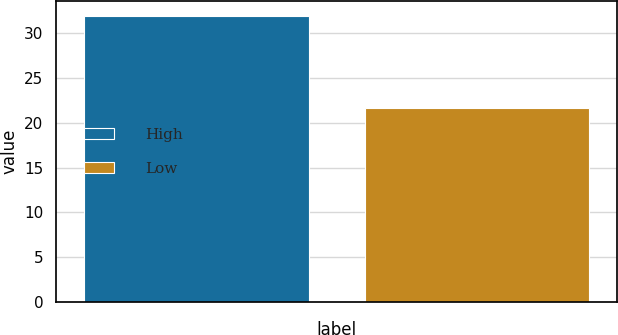<chart> <loc_0><loc_0><loc_500><loc_500><bar_chart><fcel>High<fcel>Low<nl><fcel>31.95<fcel>21.62<nl></chart> 